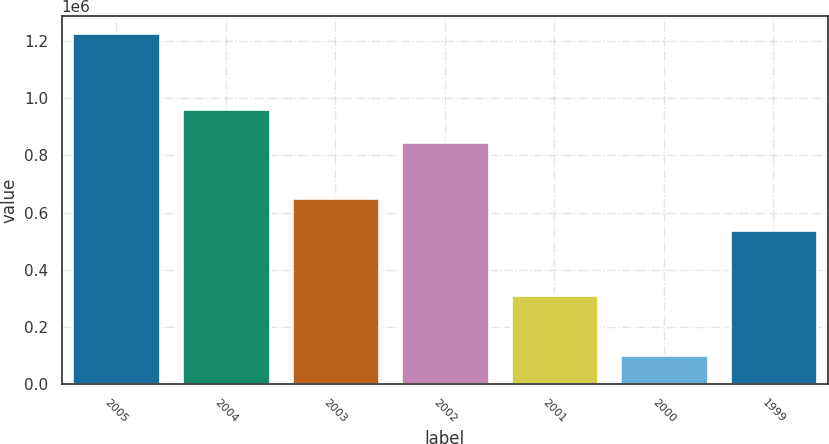Convert chart to OTSL. <chart><loc_0><loc_0><loc_500><loc_500><bar_chart><fcel>2005<fcel>2004<fcel>2003<fcel>2002<fcel>2001<fcel>2000<fcel>1999<nl><fcel>1.2277e+06<fcel>960805<fcel>651755<fcel>848050<fcel>311300<fcel>100150<fcel>539000<nl></chart> 